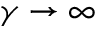Convert formula to latex. <formula><loc_0><loc_0><loc_500><loc_500>\gamma \to \infty</formula> 